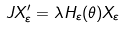<formula> <loc_0><loc_0><loc_500><loc_500>J X _ { \varepsilon } ^ { \prime } = \lambda H _ { \varepsilon } ( \theta ) X _ { \varepsilon }</formula> 